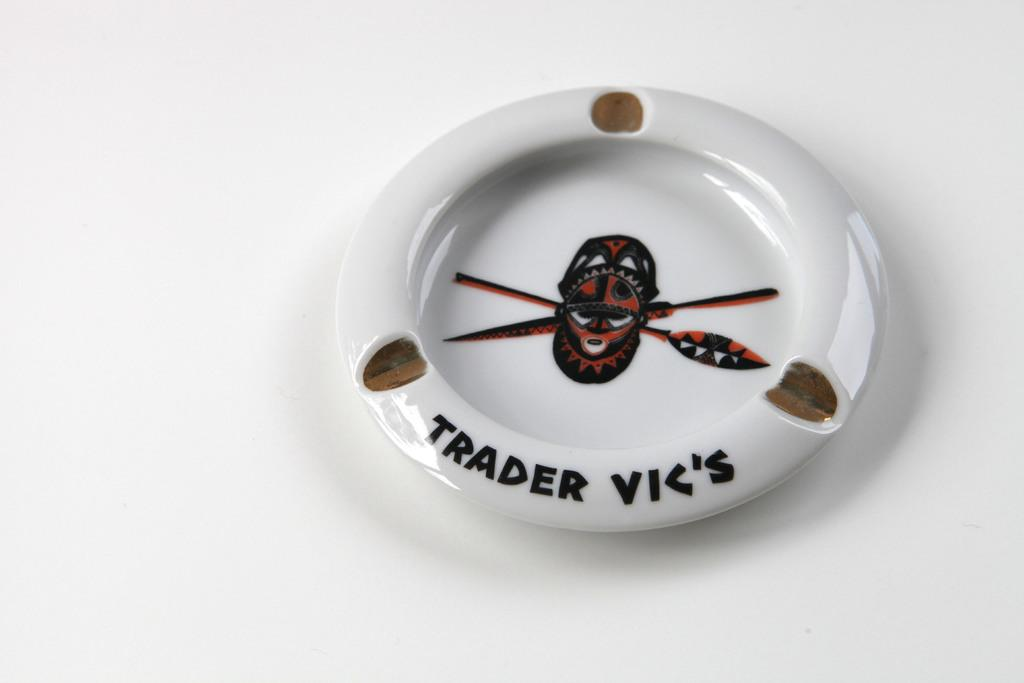What object can be seen in the image? There is a plate in the image. What is featured on the plate besides the background? There is text and a picture art in the center of the plate. What color is the background of the plate? The background of the plate is white. How does the pollution affect the selection of the wing in the image? There is no mention of pollution, selection, or wing in the image; it only features a plate with text and a picture art. 